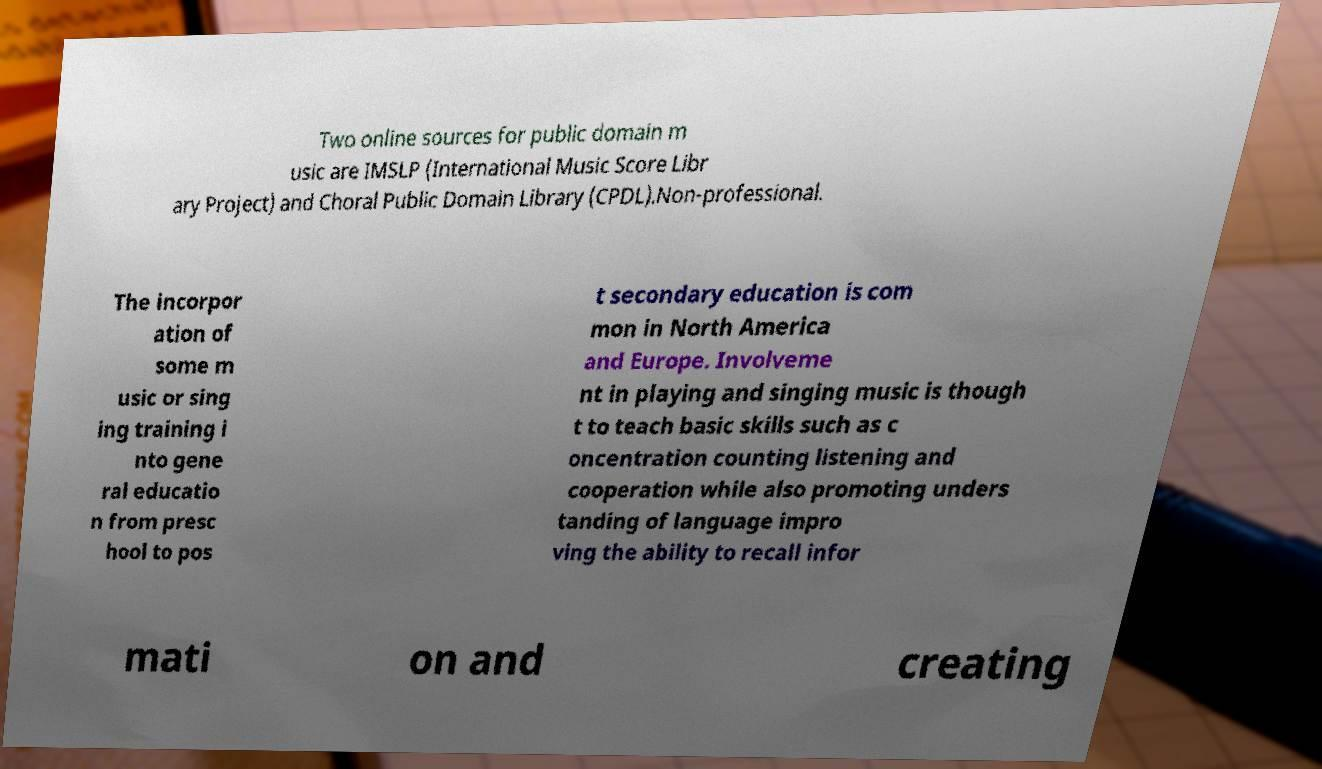I need the written content from this picture converted into text. Can you do that? Two online sources for public domain m usic are IMSLP (International Music Score Libr ary Project) and Choral Public Domain Library (CPDL).Non-professional. The incorpor ation of some m usic or sing ing training i nto gene ral educatio n from presc hool to pos t secondary education is com mon in North America and Europe. Involveme nt in playing and singing music is though t to teach basic skills such as c oncentration counting listening and cooperation while also promoting unders tanding of language impro ving the ability to recall infor mati on and creating 